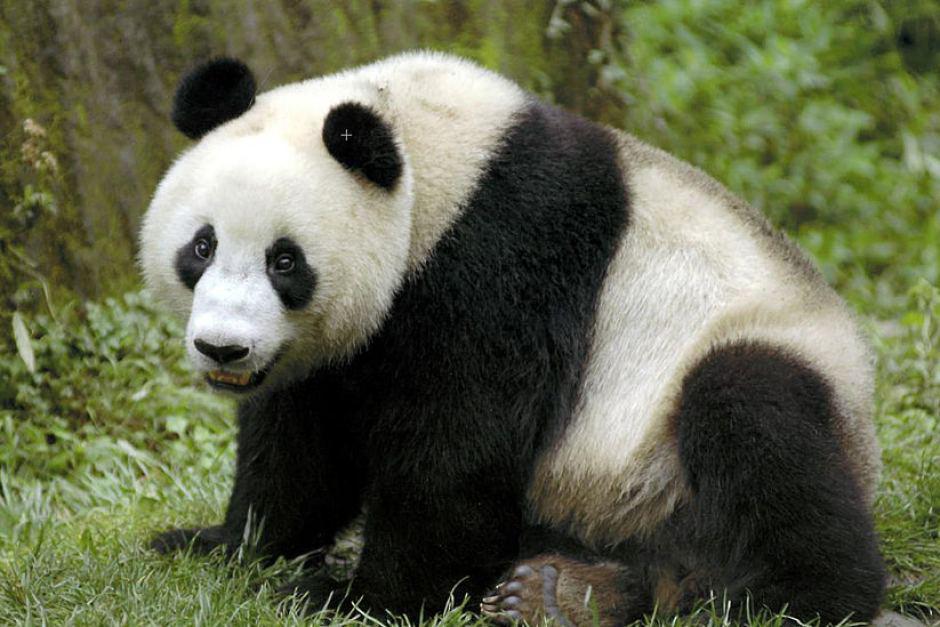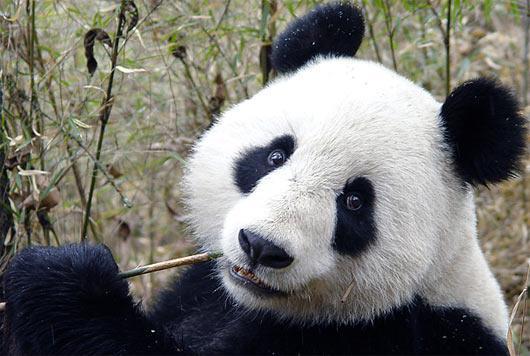The first image is the image on the left, the second image is the image on the right. Assess this claim about the two images: "In one of the images there are two pandas huddled together.". Correct or not? Answer yes or no. No. 